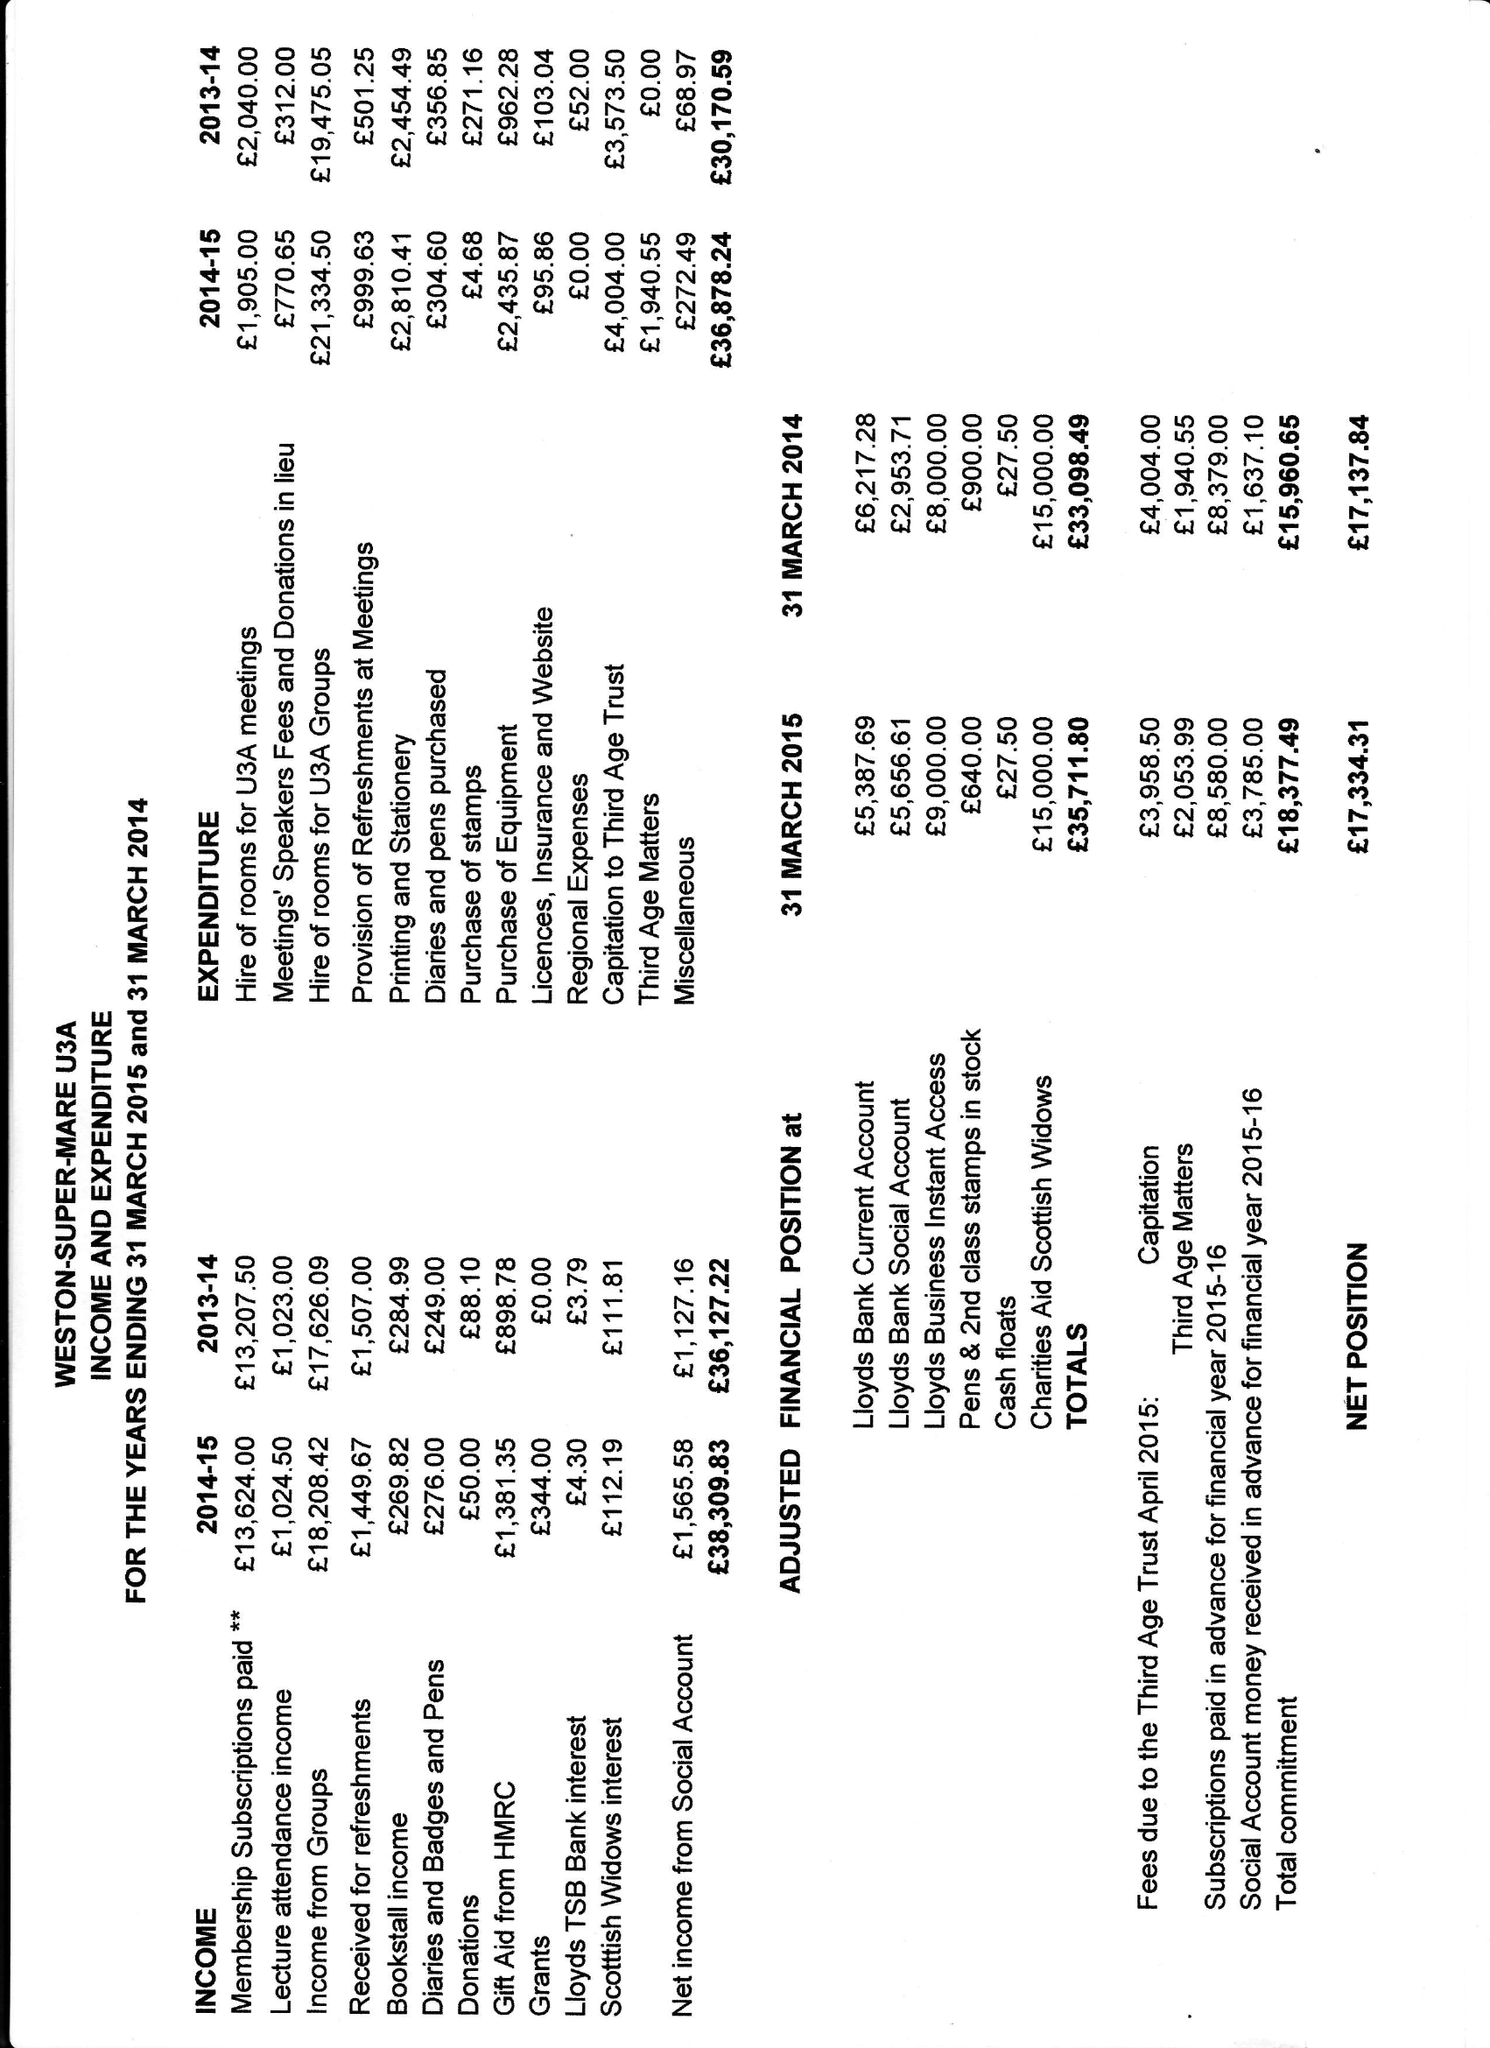What is the value for the charity_number?
Answer the question using a single word or phrase. 1048773 